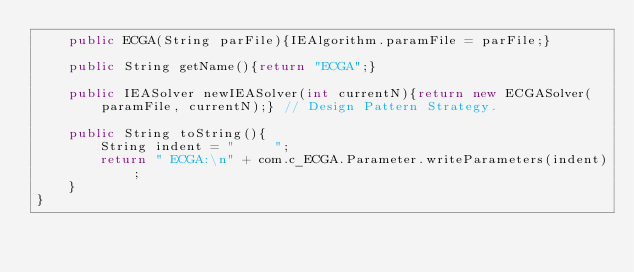<code> <loc_0><loc_0><loc_500><loc_500><_Java_>	public ECGA(String parFile){IEAlgorithm.paramFile = parFile;}
	
	public String getName(){return "ECGA";}
	
	public IEASolver newIEASolver(int currentN){return new ECGASolver(paramFile, currentN);} // Design Pattern Strategy.
	
	public String toString(){
		String indent = "     ";
		return " ECGA:\n" + com.c_ECGA.Parameter.writeParameters(indent);
	}
}


</code> 